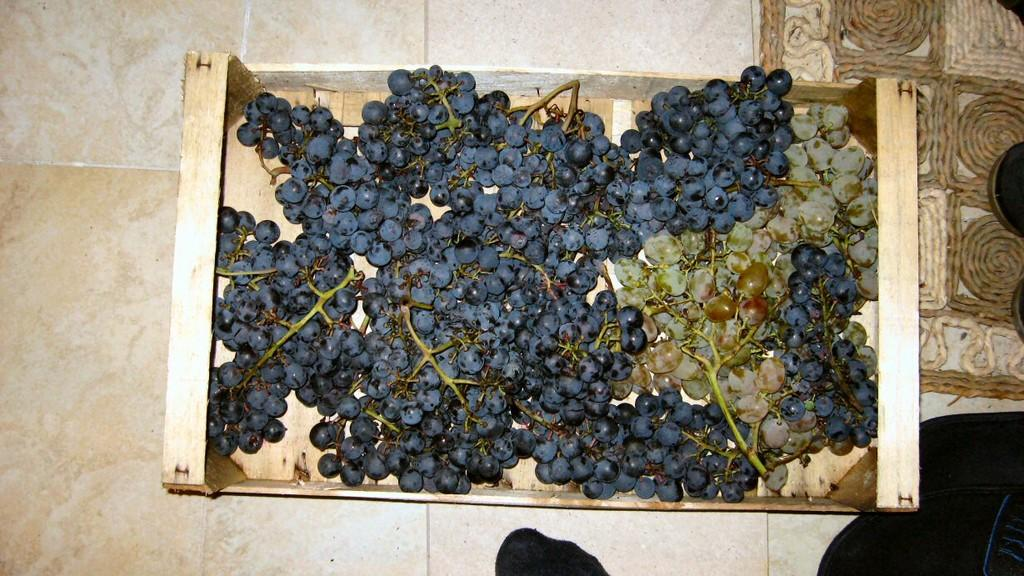What type of fruit is present in the image? There are grapes in the image. How are the grapes contained in the image? The grapes are in a box. What surface is visible at the bottom of the image? There is a floor visible at the bottom of the image. What type of ink can be seen dripping from the grapes in the image? There is no ink present in the image, and the grapes are not dripping anything. 